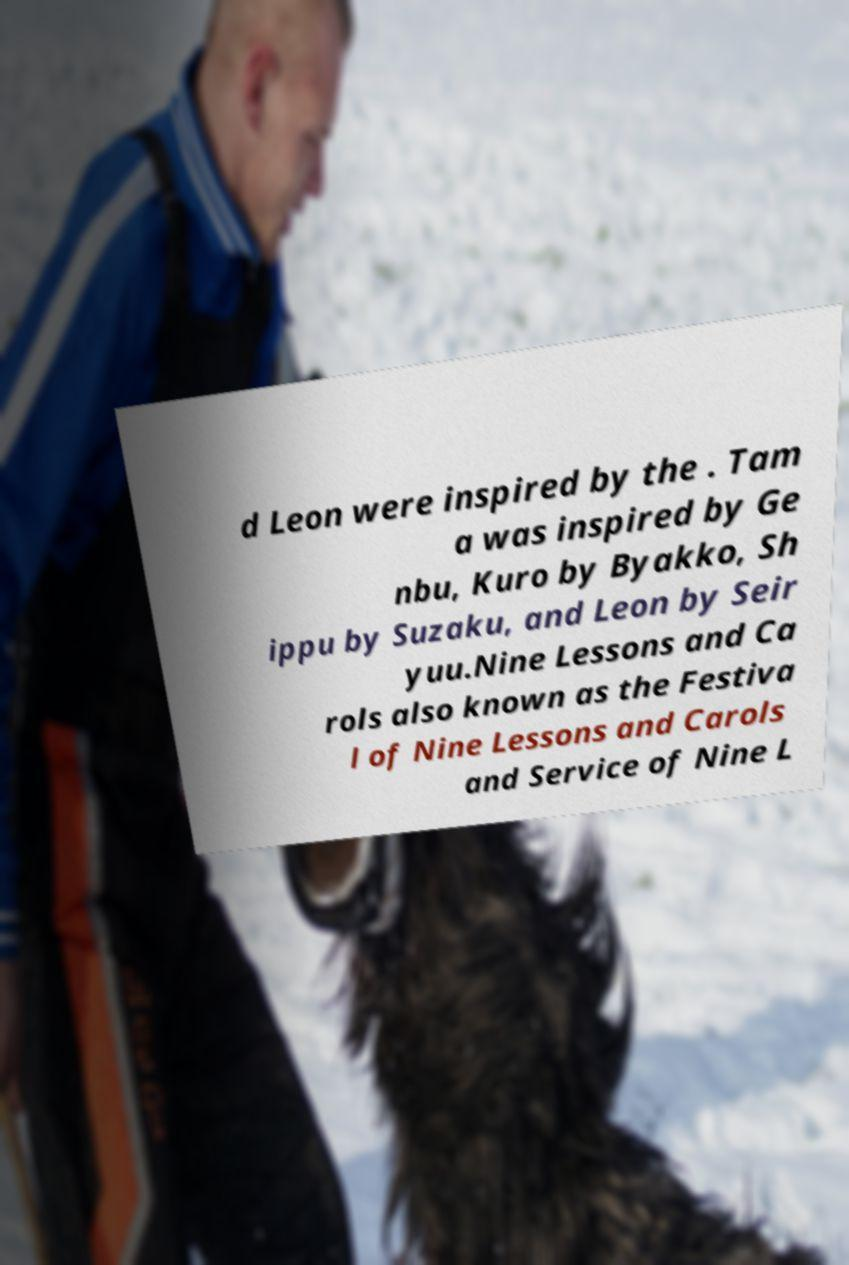Can you read and provide the text displayed in the image?This photo seems to have some interesting text. Can you extract and type it out for me? d Leon were inspired by the . Tam a was inspired by Ge nbu, Kuro by Byakko, Sh ippu by Suzaku, and Leon by Seir yuu.Nine Lessons and Ca rols also known as the Festiva l of Nine Lessons and Carols and Service of Nine L 